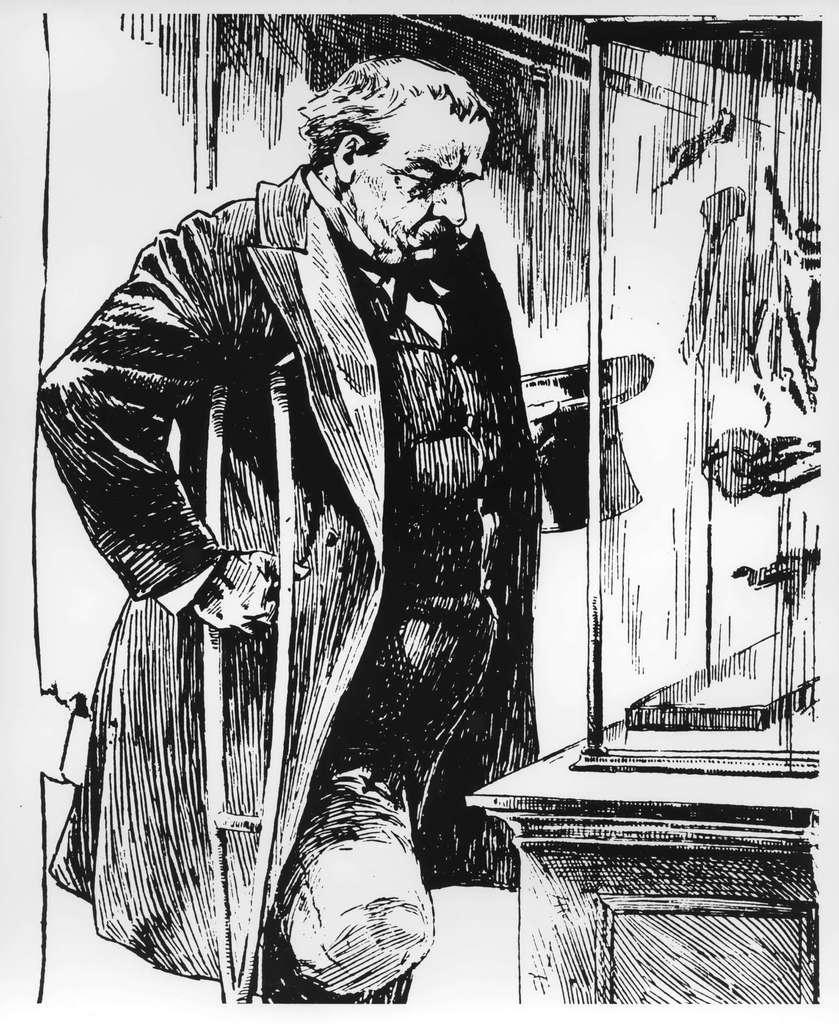Please provide a concise description of this image. This picture is consists of a sketch. 